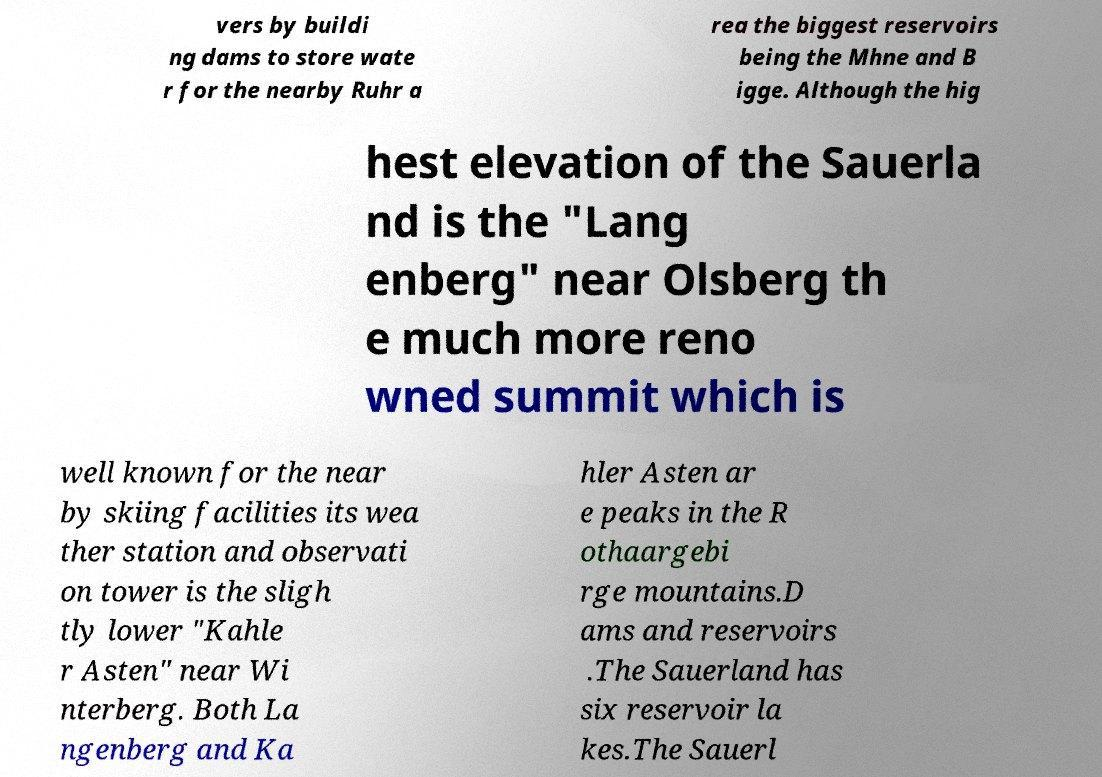Can you accurately transcribe the text from the provided image for me? vers by buildi ng dams to store wate r for the nearby Ruhr a rea the biggest reservoirs being the Mhne and B igge. Although the hig hest elevation of the Sauerla nd is the "Lang enberg" near Olsberg th e much more reno wned summit which is well known for the near by skiing facilities its wea ther station and observati on tower is the sligh tly lower "Kahle r Asten" near Wi nterberg. Both La ngenberg and Ka hler Asten ar e peaks in the R othaargebi rge mountains.D ams and reservoirs .The Sauerland has six reservoir la kes.The Sauerl 